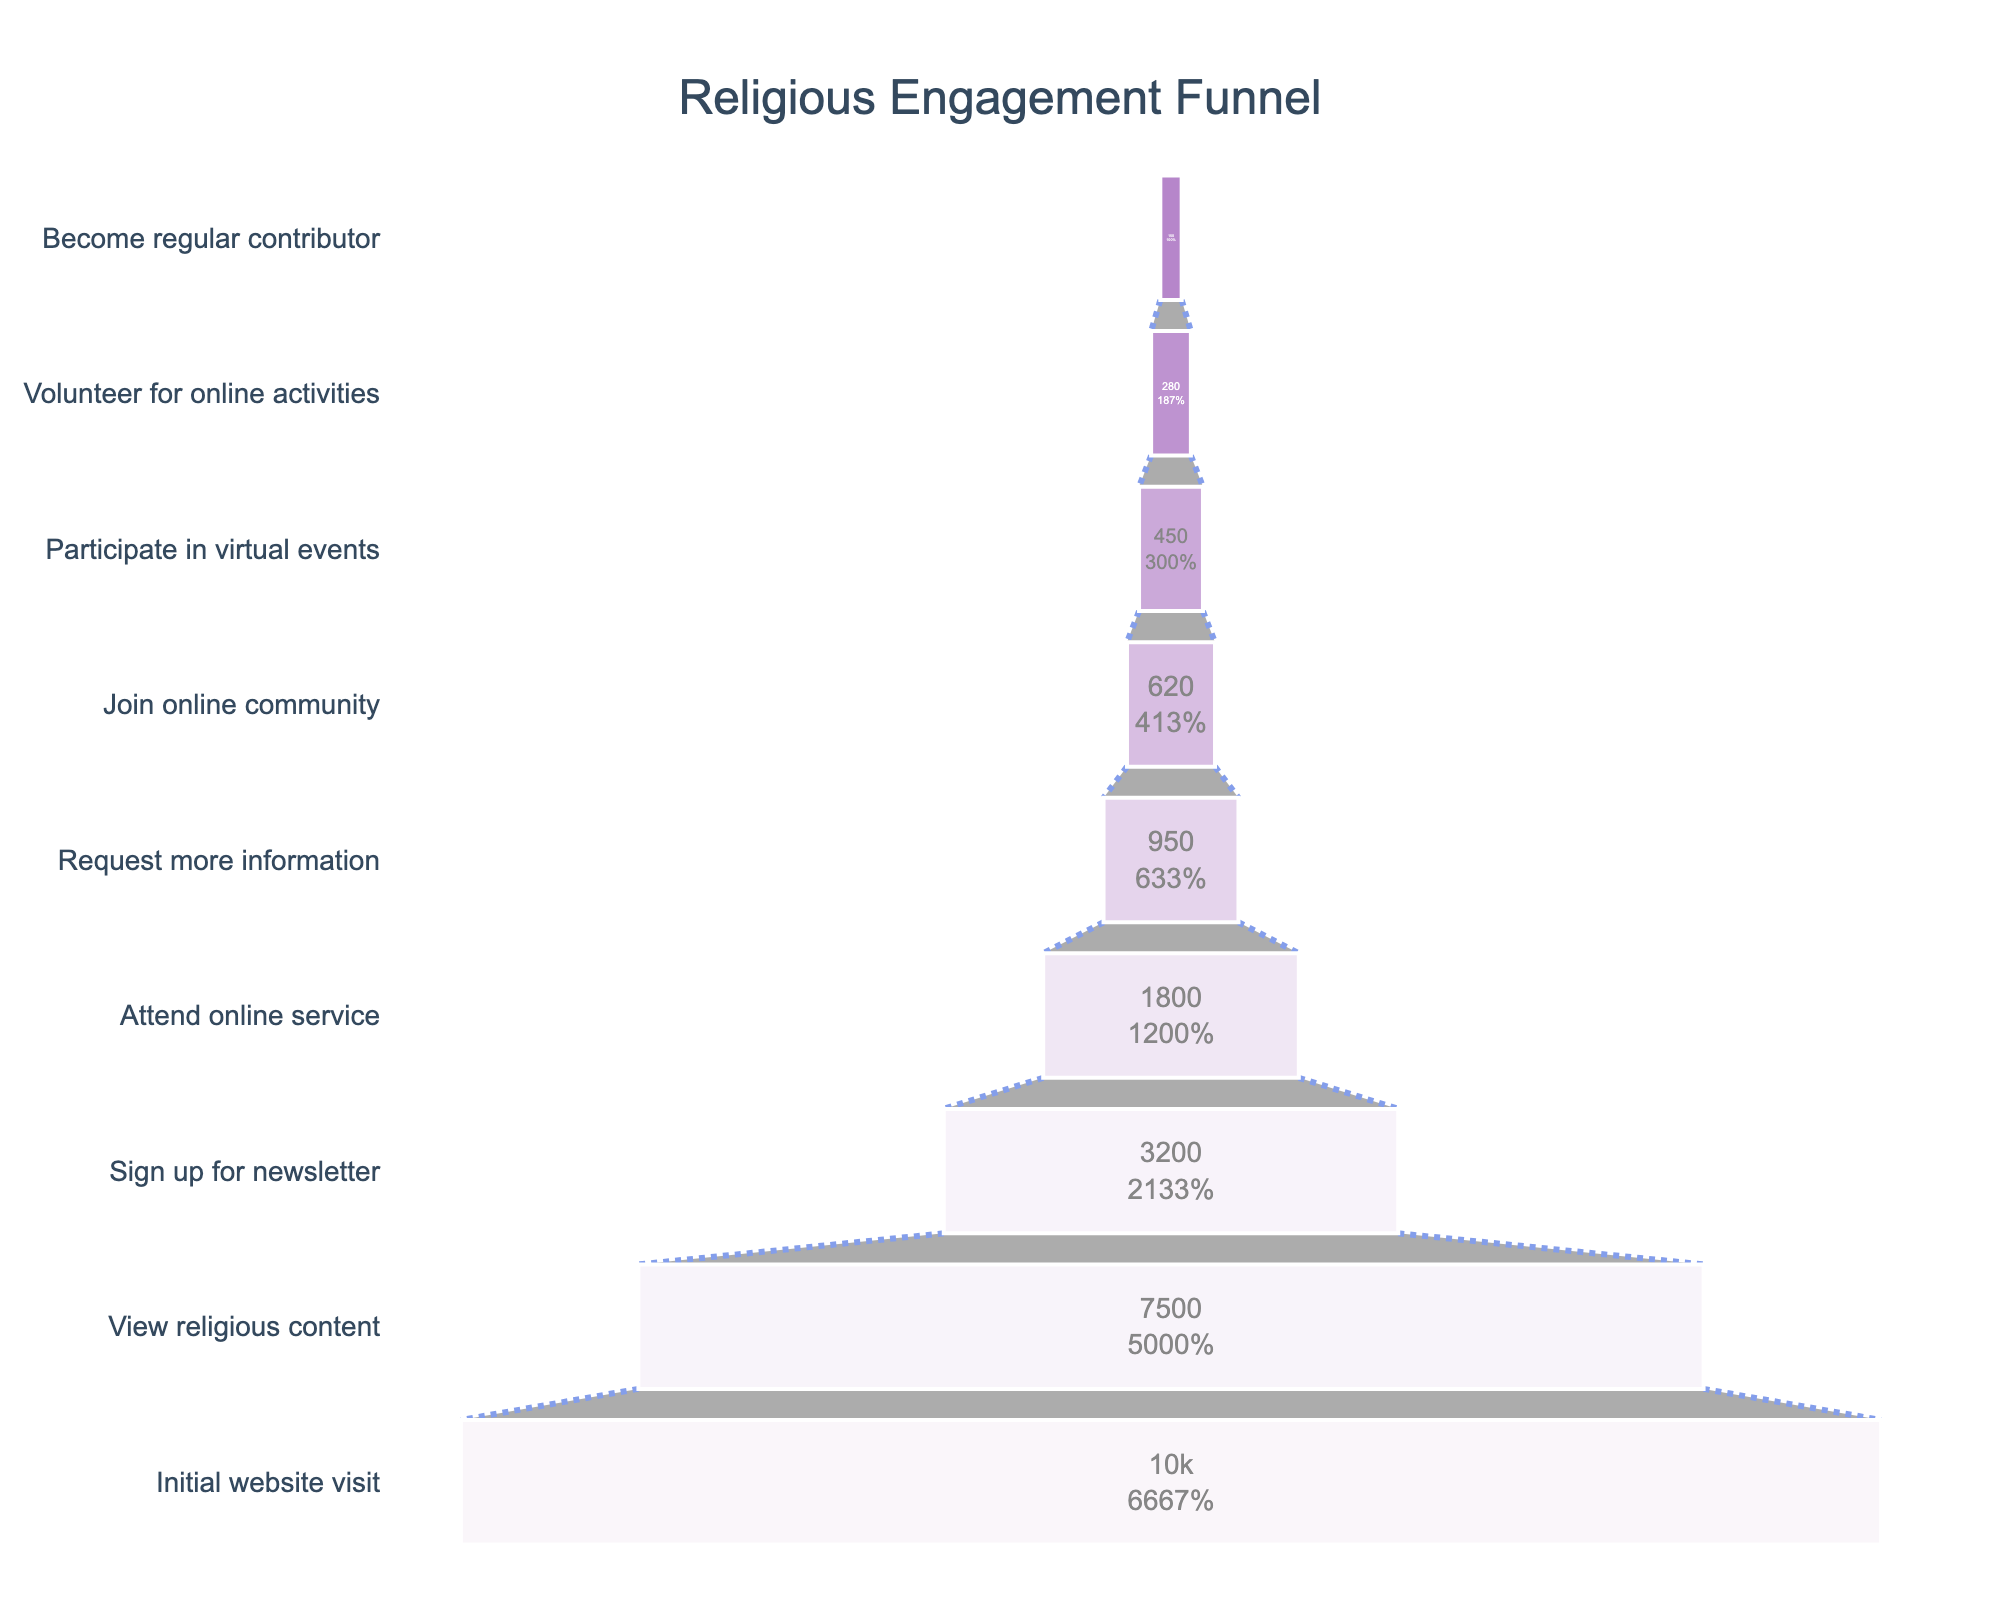What is the title of the funnel chart? The title of the funnel chart is prominently displayed at the top of the figure. It reads "Religious Engagement Funnel".
Answer: Religious Engagement Funnel How many stages are there in the funnel chart? By counting the distinct stages listed on the y-axis of the funnel chart, there are 9 stages in total.
Answer: 9 What percentage of initial website visitors view religious content? From the chart, trace the "View religious content" stage to its corresponding percentage. It is shown as a percentage of the initial 10,000 visitors.
Answer: 75% How many visitors sign up for the newsletter? Navigate to the stage "Sign up for newsletter" on the chart to identify the number of visitors at that stage, which is clearly labeled.
Answer: 3200 What's the difference in the number of visitors between those who request more information and those who join the online community? Look at the visitor numbers for both "Request more information" (950) and "Join online community" (620). Subtract the latter from the former: 950 - 620 = 330.
Answer: 330 What percentage of visitors who attend the online service go on to request more information? Note the number of visitors who "Attend online service" (1800) and those who "Request more information" (950). Calculate the percentage: (950/1800) * 100 ≈ 52.78%.
Answer: 52.78% How many more visitors participate in virtual events compared to those who volunteer for online activities? Find the visitor counts for "Participate in virtual events" (450) and "Volunteer for online activities" (280). The difference is 450 - 280 = 170.
Answer: 170 Which stage experiences the highest dropout rate in visitor numbers? Compare the differences in visitor numbers between each consecutive stage. The largest drop is from "Sign up for newsletter" (3200) to "Attend online service" (1800), a drop of 1400 visitors.
Answer: Sign up for newsletter to Attend online service What is the final percentage of visitors who become regular contributors compared to the initial website visitors? Note the final stage "Become regular contributor" counts 150 visitors. The initial number is 10,000. Calculate the percentage: (150/10000) * 100 = 1.5%.
Answer: 1.5% Which two stages have the closest number of visitors? Compare the number of visitors at each stage. The closest figures are between "Attend online service" (1800) and "Request more information" (950), with a difference of 850, but look closely, "Participate in virtual events" (450) and "Volunteer for online activities" (280), with a difference of 170, are closer.
Answer: Participate in virtual events and Volunteer for online activities 